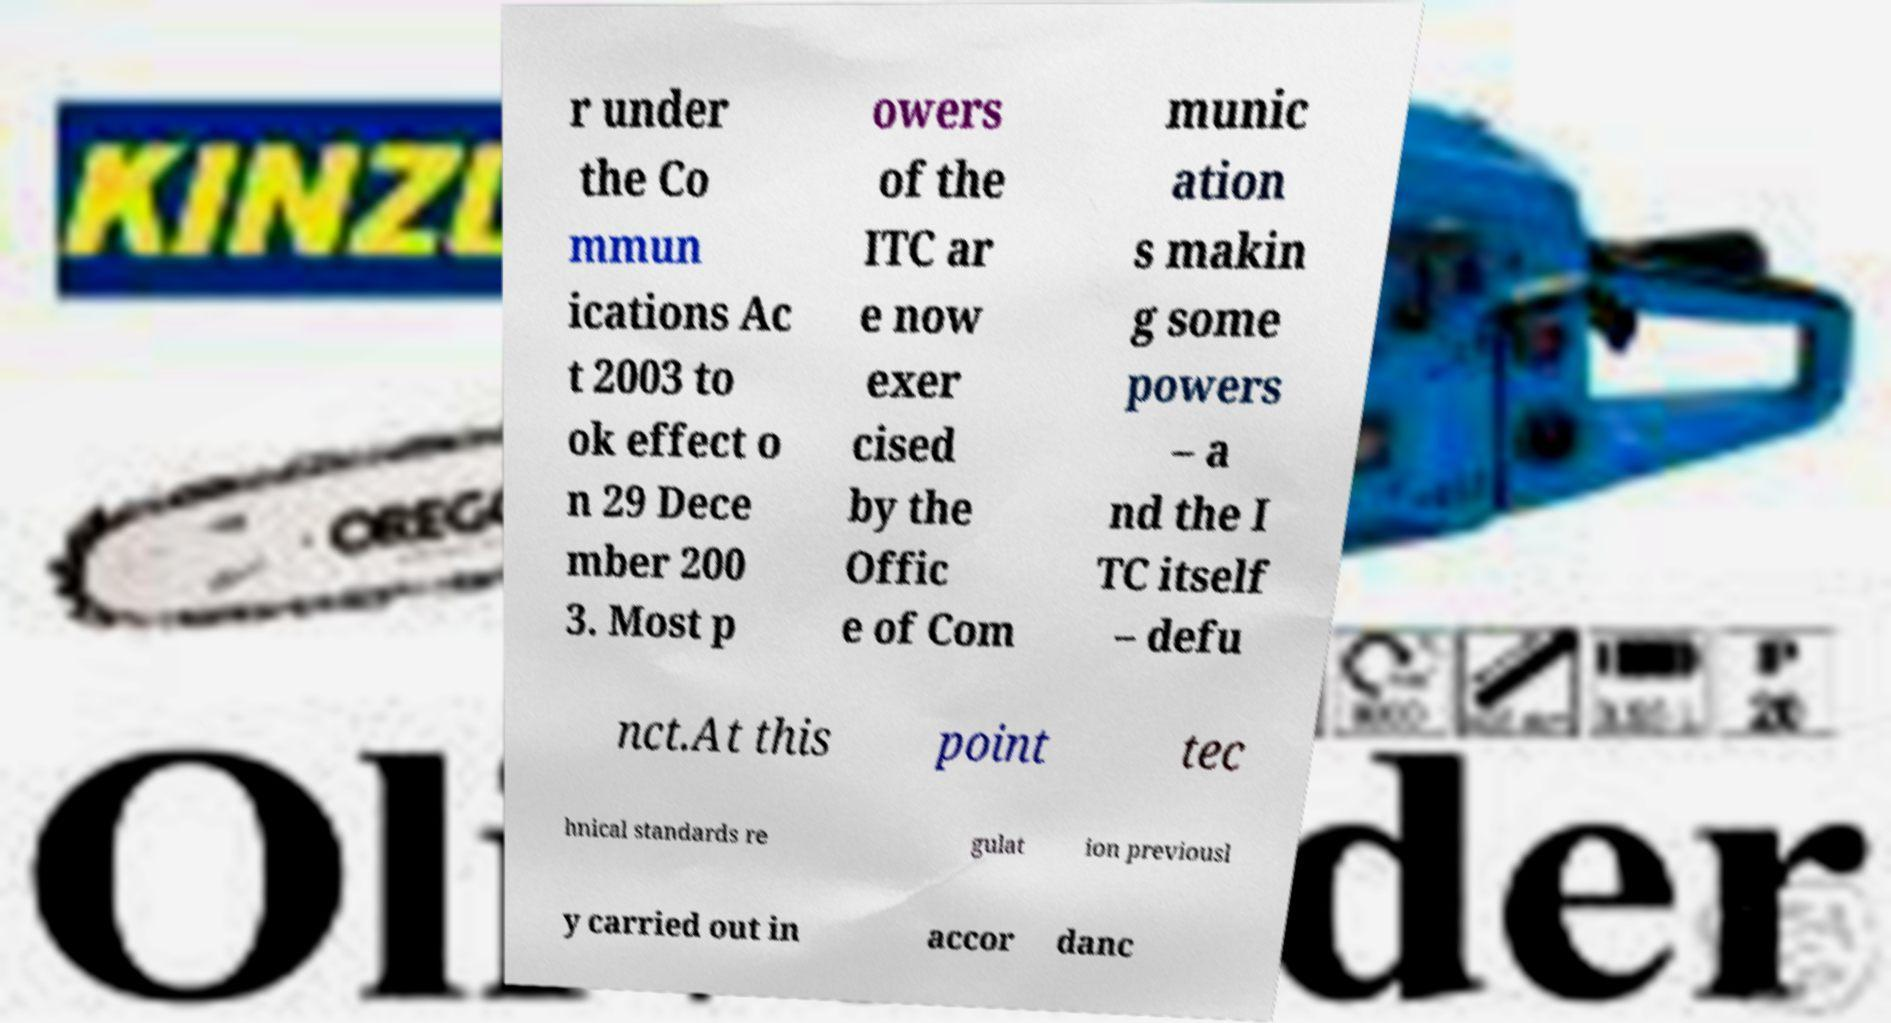Please read and relay the text visible in this image. What does it say? r under the Co mmun ications Ac t 2003 to ok effect o n 29 Dece mber 200 3. Most p owers of the ITC ar e now exer cised by the Offic e of Com munic ation s makin g some powers – a nd the I TC itself – defu nct.At this point tec hnical standards re gulat ion previousl y carried out in accor danc 